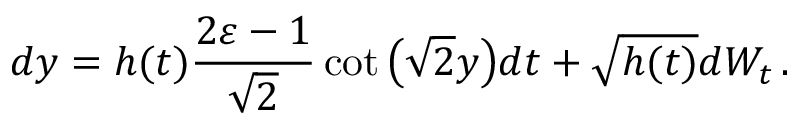Convert formula to latex. <formula><loc_0><loc_0><loc_500><loc_500>d y = h ( t ) \frac { 2 \varepsilon - 1 } { \sqrt { 2 } } \cot \left ( \sqrt { 2 } y \right ) d t + \sqrt { h ( t ) } d W _ { t } \, .</formula> 